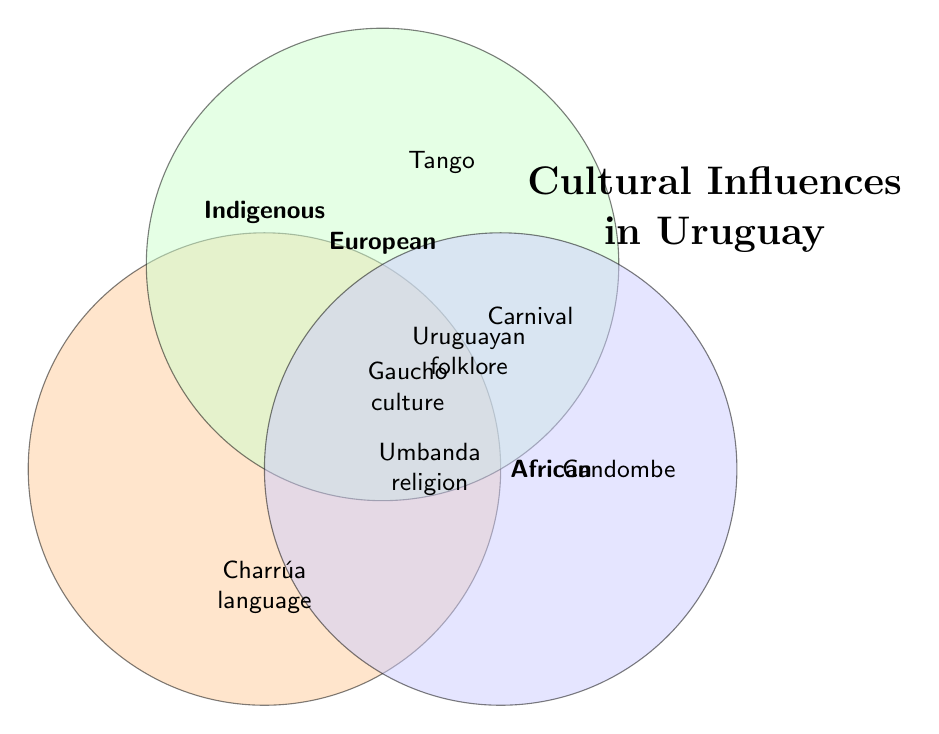What are the three cultural influences mentioned in the title? The title of the diagram is "Cultural Influences in Uruguay," and it names the three influences as Indigenous, European, and African.
Answer: Indigenous, European, African What tradition overlaps between Indigenous and European cultures according to the Venn diagram? The overlapping area of Indigenous and European cultures in the Venn diagram indicates "Gaucho culture."
Answer: Gaucho culture Which single cultural element is attributed solely to Indigenous influence? The part of the Venn diagram that represents only Indigenous influence lists "Charrúa language."
Answer: Charrúa language How many cultural elements are common to all three influences: Indigenous, European, and African? The center area where all three circles intersect lists "Uruguayan folklore." Thus, there is one element.
Answer: 1 Which African cultural element is also influenced by Indigenous culture but not European? The overlap between Indigenous and African cultures shows the element "Umbanda religion."
Answer: Umbanda religion How does "Carnival" overlap in the Venn diagram? The element "Carnival celebrations" is found in the overlap between Indigenous, European, and African cultures.
Answer: Indigenous, European, African What specific element is listed under European influence alone? The section of the Venn diagram for European influence alone lists "Tango."
Answer: Tango How many cultural elements are part of European and African influences together but not Indigenous? The intersection between European and African spheres lists "Carnival celebrations" and "Football passion." There are two elements.
Answer: 2 Which cultural practice related to plants is attributed mainly to Indigenous influence? The section of the Venn diagram that represents only Indigenous influence includes "Medicinal plants."
Answer: Medicinal plants How many cultural elements are influenced by both African and Indigenous cultures according to the Venn diagram? The area where Indigenous and African influences overlap includes "Umbanda religion" and "Quilombos." There are two elements.
Answer: 2 